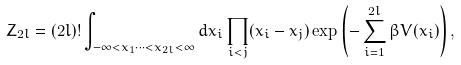<formula> <loc_0><loc_0><loc_500><loc_500>Z _ { 2 l } = ( 2 l ) ! \int _ { - \infty < x _ { 1 } \cdots < x _ { 2 l } < \infty } d x _ { i } \prod _ { i < j } ( x _ { i } - x _ { j } ) \exp \left ( - \sum _ { i = 1 } ^ { 2 l } \beta V ( x _ { i } ) \right ) ,</formula> 